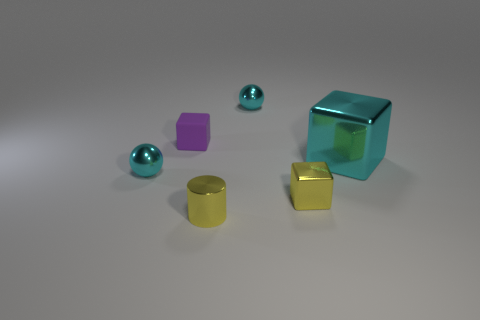Add 2 big green shiny cylinders. How many objects exist? 8 Subtract all matte blocks. How many blocks are left? 2 Subtract all balls. How many objects are left? 4 Add 6 small yellow shiny objects. How many small yellow shiny objects exist? 8 Subtract 0 green spheres. How many objects are left? 6 Subtract all brown blocks. Subtract all green balls. How many blocks are left? 3 Subtract all yellow cubes. Subtract all cyan metal cubes. How many objects are left? 4 Add 5 small purple things. How many small purple things are left? 6 